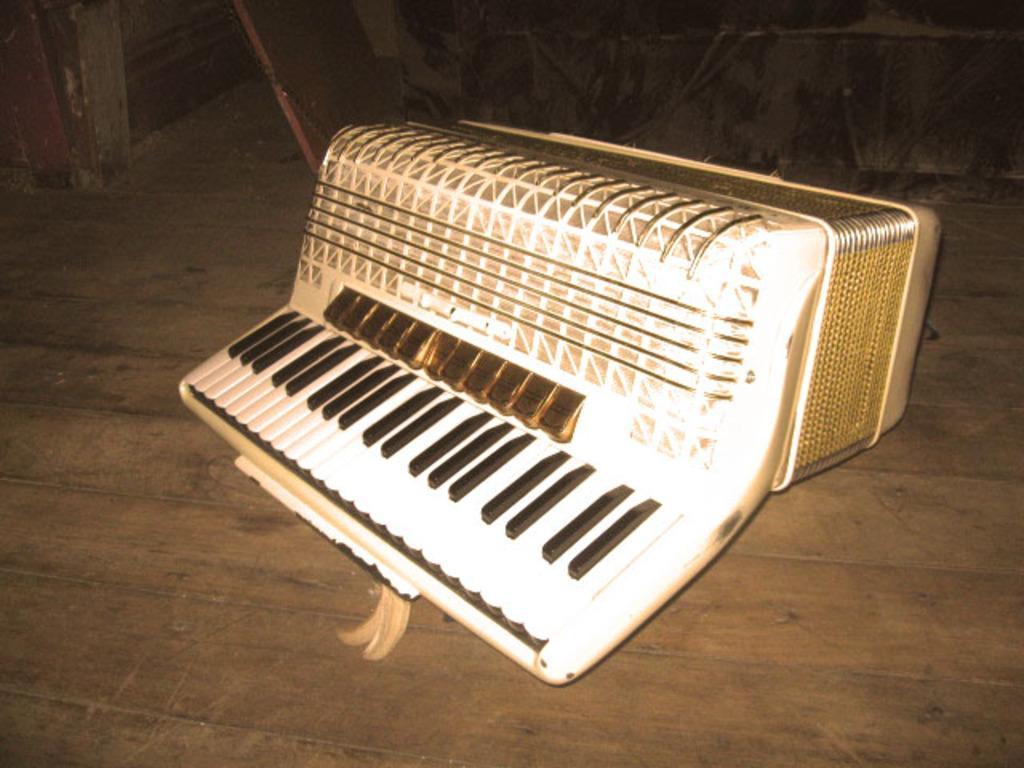Can you describe this image briefly? In this picture I can see a musical instrument in front which is on the floor. I see that it is a bit dark in the background. 